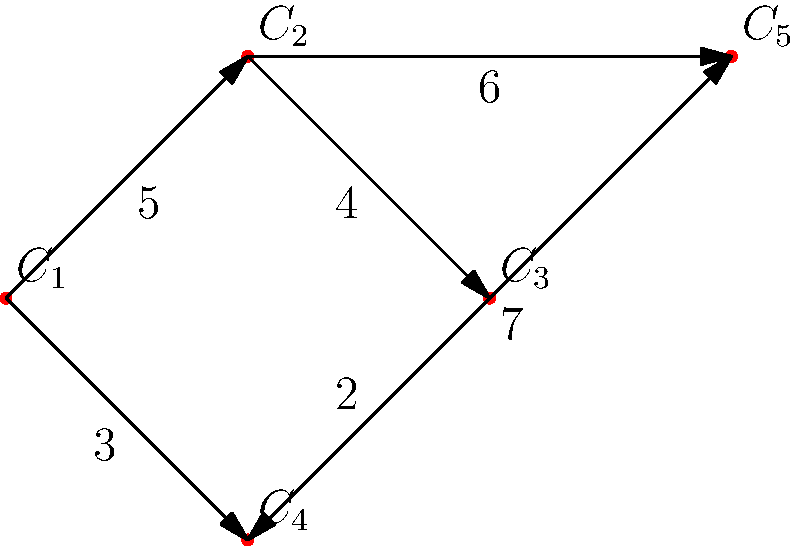As a used car parts trader, you've created a weighted graph representing customer purchase patterns. Vertices represent car part categories ($C_1$ to $C_5$), and edge weights indicate the likelihood of customers buying both connected parts together. What is the total weight of the most likely purchase path that includes exactly four different part categories? To solve this problem, we need to find the path with the highest total weight that includes exactly four vertices (part categories). Let's approach this step-by-step:

1. Identify all possible paths with four vertices:
   - $C_1 \rightarrow C_2 \rightarrow C_3 \rightarrow C_4$
   - $C_1 \rightarrow C_2 \rightarrow C_5 \rightarrow C_4$
   - $C_1 \rightarrow C_4 \rightarrow C_5 \rightarrow C_2$
   - $C_1 \rightarrow C_4 \rightarrow C_3 \rightarrow C_2$

2. Calculate the total weight for each path:
   - $C_1 \rightarrow C_2 \rightarrow C_3 \rightarrow C_4$: $5 + 4 + 2 = 11$
   - $C_1 \rightarrow C_2 \rightarrow C_5 \rightarrow C_4$: $5 + 6 + 7 = 18$
   - $C_1 \rightarrow C_4 \rightarrow C_5 \rightarrow C_2$: $3 + 7 + 6 = 16$
   - $C_1 \rightarrow C_4 \rightarrow C_3 \rightarrow C_2$: $3 + 2 + 4 = 9$

3. Identify the path with the highest total weight:
   The path $C_1 \rightarrow C_2 \rightarrow C_5 \rightarrow C_4$ has the highest total weight of 18.

Therefore, the most likely purchase path that includes exactly four different part categories has a total weight of 18.
Answer: 18 